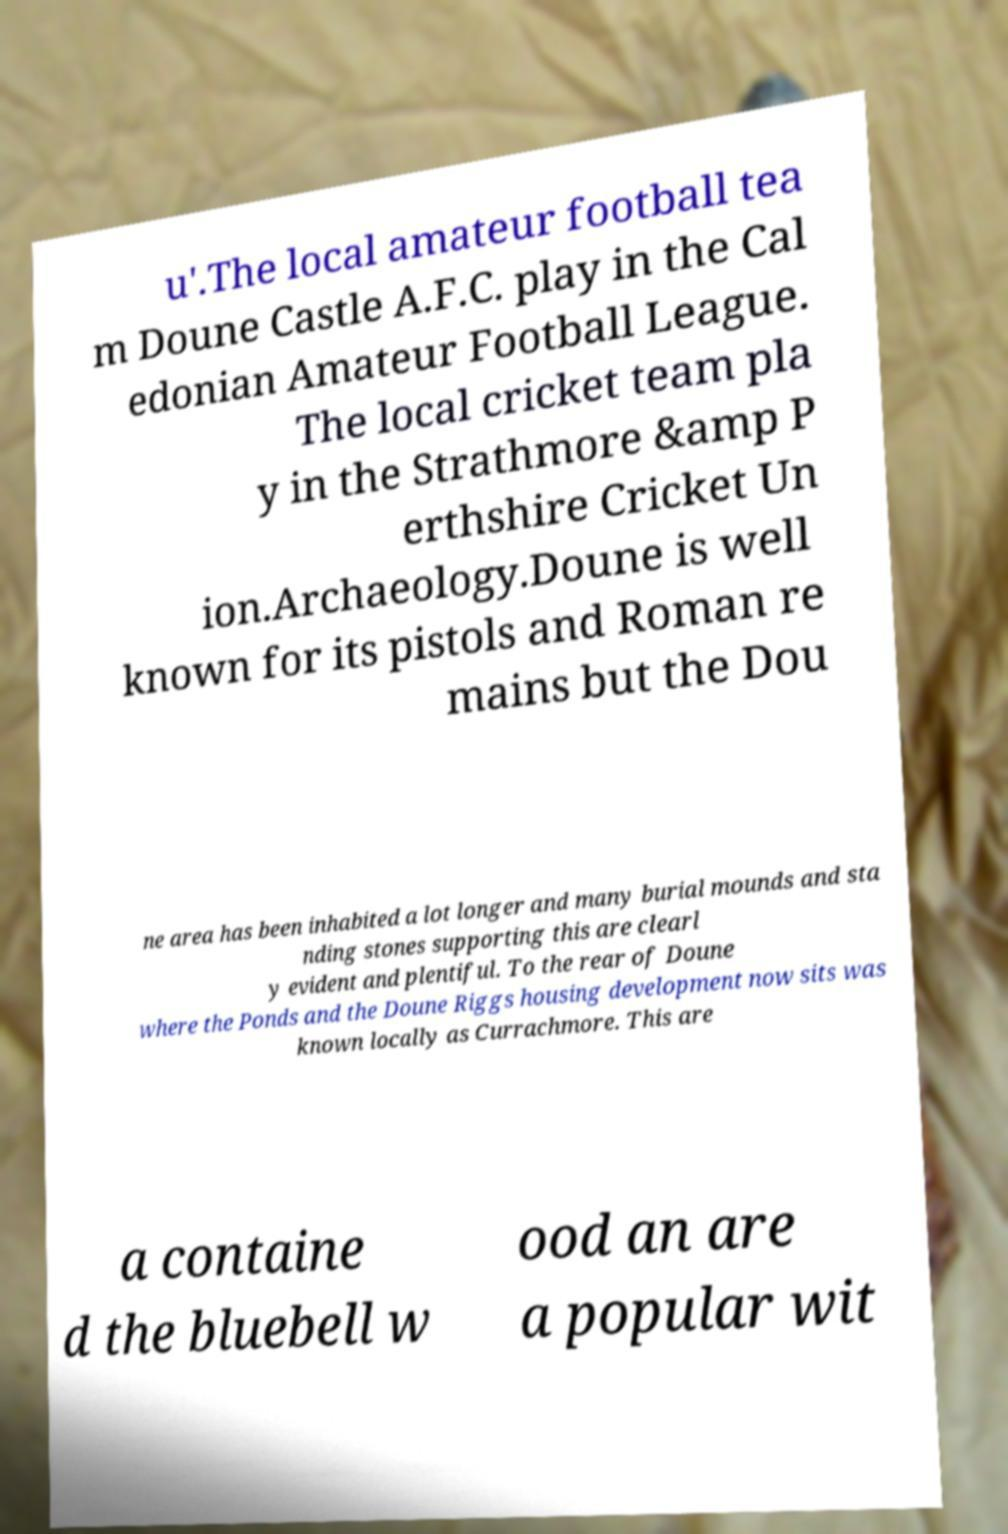Could you assist in decoding the text presented in this image and type it out clearly? u'.The local amateur football tea m Doune Castle A.F.C. play in the Cal edonian Amateur Football League. The local cricket team pla y in the Strathmore &amp P erthshire Cricket Un ion.Archaeology.Doune is well known for its pistols and Roman re mains but the Dou ne area has been inhabited a lot longer and many burial mounds and sta nding stones supporting this are clearl y evident and plentiful. To the rear of Doune where the Ponds and the Doune Riggs housing development now sits was known locally as Currachmore. This are a containe d the bluebell w ood an are a popular wit 